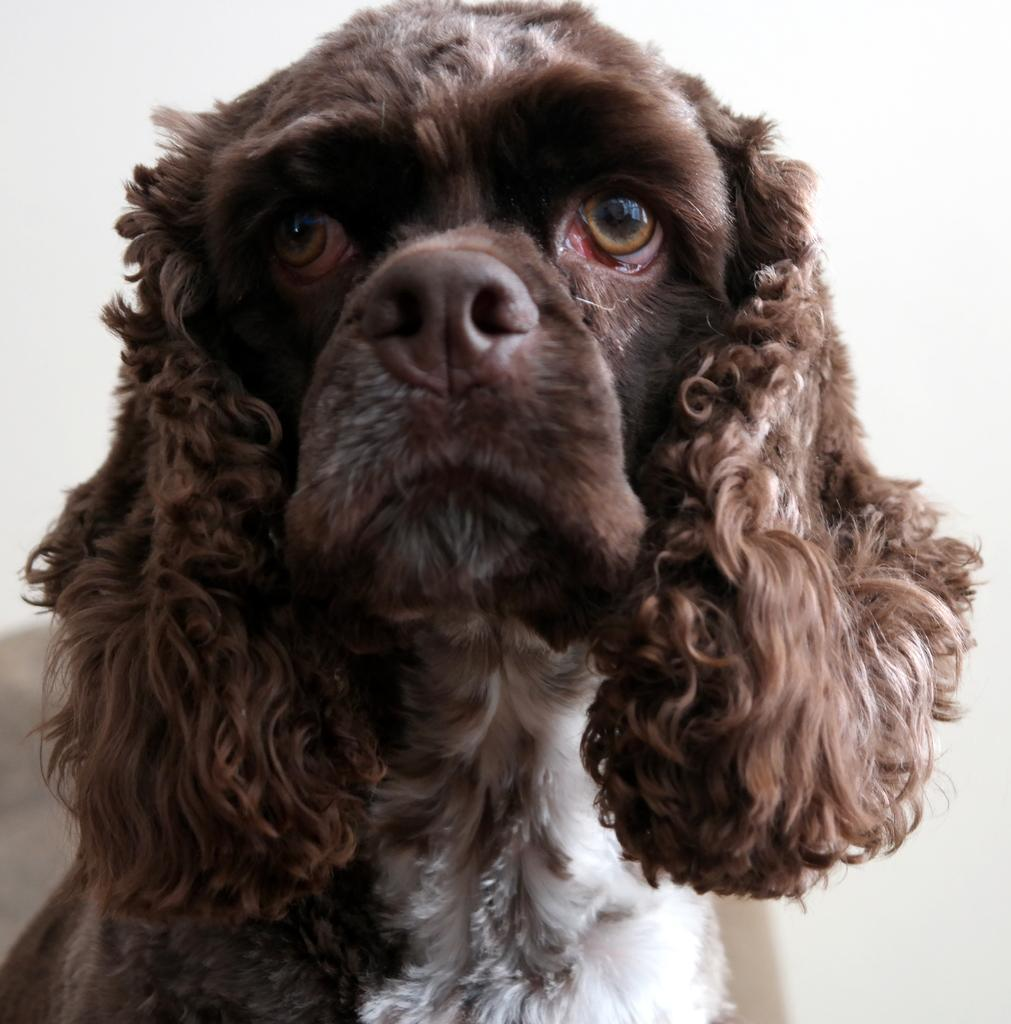What is the main subject in the center of the image? There is a dog in the center of the image. What can be seen in the background of the image? There is a wall in the background of the image. How many people are in the crowd surrounding the dog in the image? There is no crowd present in the image; it only features a dog and a wall in the background. 